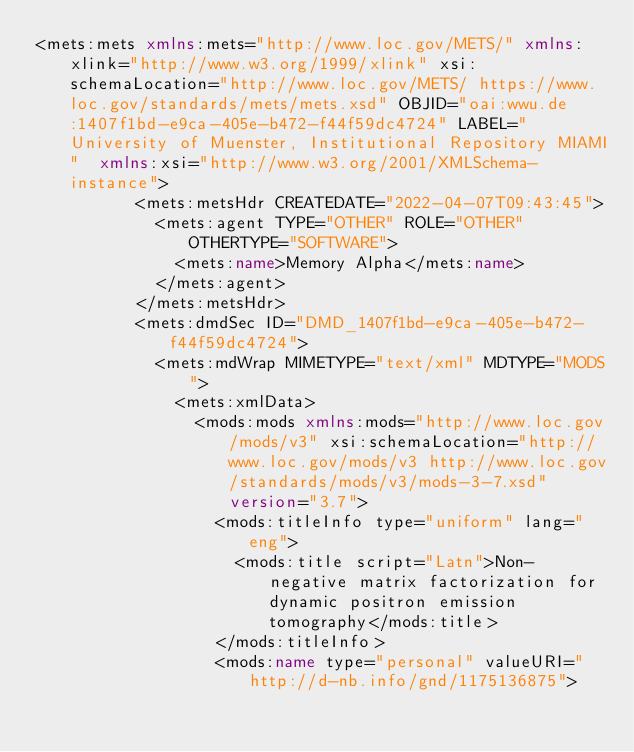Convert code to text. <code><loc_0><loc_0><loc_500><loc_500><_XML_><mets:mets xmlns:mets="http://www.loc.gov/METS/" xmlns:xlink="http://www.w3.org/1999/xlink" xsi:schemaLocation="http://www.loc.gov/METS/ https://www.loc.gov/standards/mets/mets.xsd" OBJID="oai:wwu.de:1407f1bd-e9ca-405e-b472-f44f59dc4724" LABEL="University of Muenster, Institutional Repository MIAMI"  xmlns:xsi="http://www.w3.org/2001/XMLSchema-instance">
          <mets:metsHdr CREATEDATE="2022-04-07T09:43:45">
            <mets:agent TYPE="OTHER" ROLE="OTHER" OTHERTYPE="SOFTWARE">
              <mets:name>Memory Alpha</mets:name>
            </mets:agent>
          </mets:metsHdr>
          <mets:dmdSec ID="DMD_1407f1bd-e9ca-405e-b472-f44f59dc4724">
            <mets:mdWrap MIMETYPE="text/xml" MDTYPE="MODS">
              <mets:xmlData>
                <mods:mods xmlns:mods="http://www.loc.gov/mods/v3" xsi:schemaLocation="http://www.loc.gov/mods/v3 http://www.loc.gov/standards/mods/v3/mods-3-7.xsd" version="3.7">
                  <mods:titleInfo type="uniform" lang="eng">
                    <mods:title script="Latn">Non-negative matrix factorization for dynamic positron emission tomography</mods:title>
                  </mods:titleInfo>
                  <mods:name type="personal" valueURI="http://d-nb.info/gnd/1175136875"></code> 